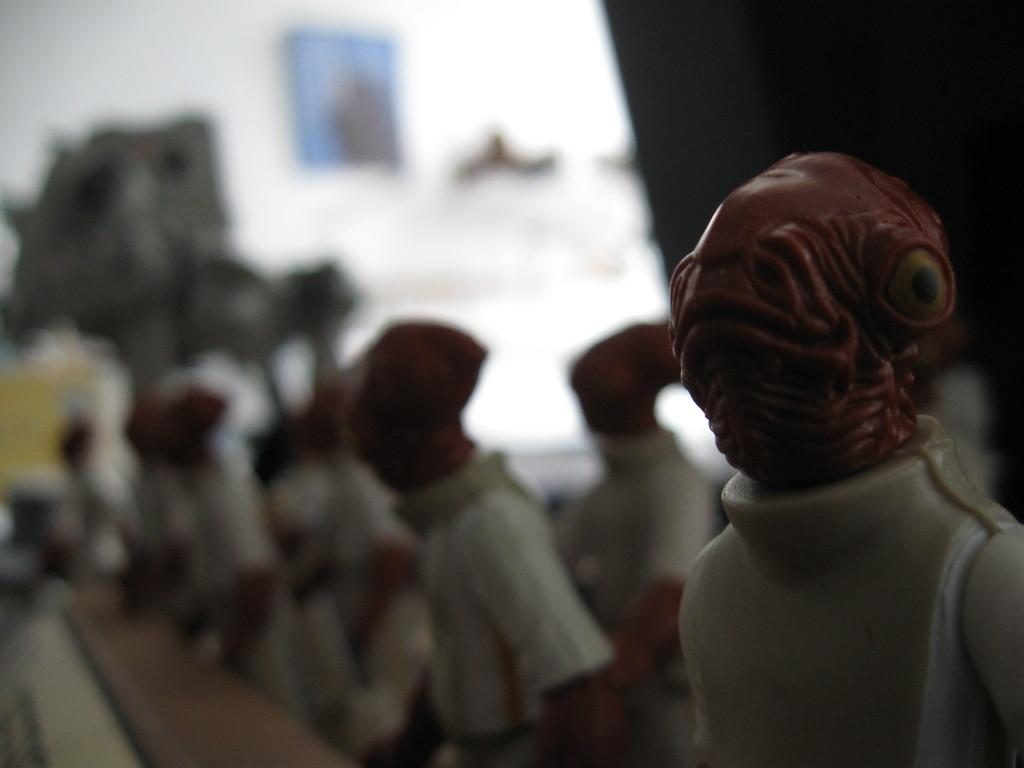What objects can be seen in the image? There are toys in the image. Can you describe anything on the wall in the image? There is a portrait on the wall in the image. How many sheep are visible in the image? There are no sheep present in the image. What is the balance of zinc in the image? The balance of zinc cannot be determined from the image, as it is not a chemical element that can be observed visually. 